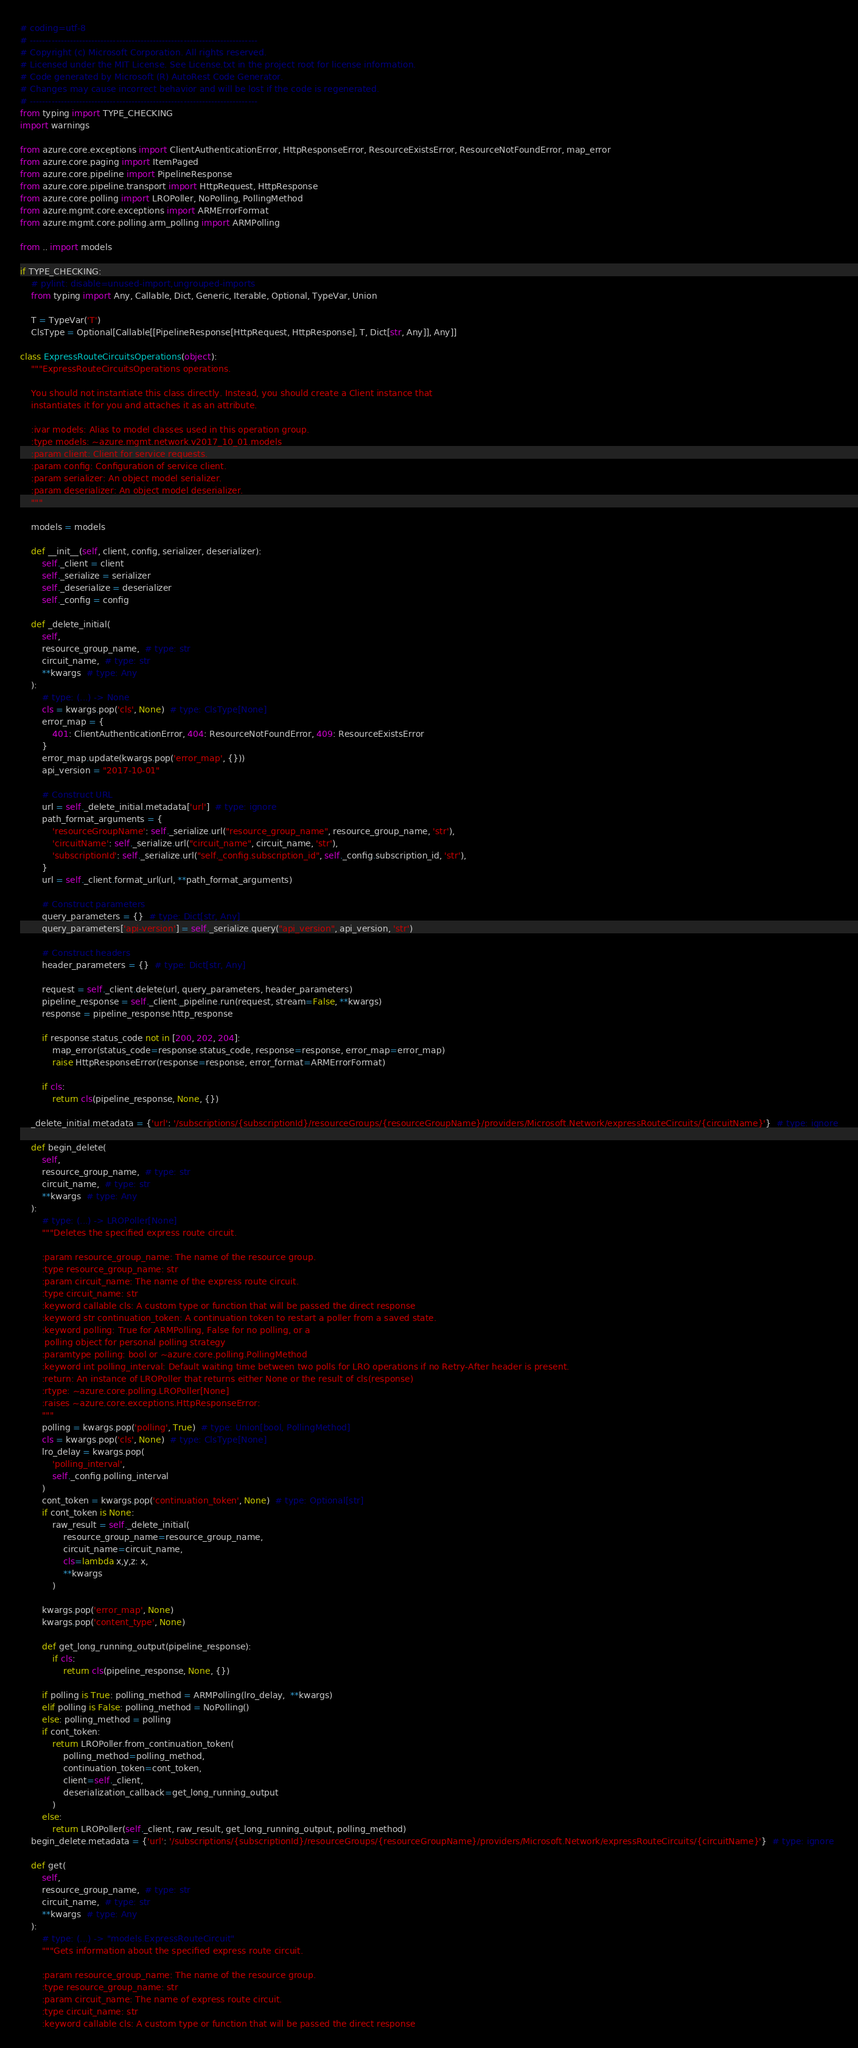<code> <loc_0><loc_0><loc_500><loc_500><_Python_># coding=utf-8
# --------------------------------------------------------------------------
# Copyright (c) Microsoft Corporation. All rights reserved.
# Licensed under the MIT License. See License.txt in the project root for license information.
# Code generated by Microsoft (R) AutoRest Code Generator.
# Changes may cause incorrect behavior and will be lost if the code is regenerated.
# --------------------------------------------------------------------------
from typing import TYPE_CHECKING
import warnings

from azure.core.exceptions import ClientAuthenticationError, HttpResponseError, ResourceExistsError, ResourceNotFoundError, map_error
from azure.core.paging import ItemPaged
from azure.core.pipeline import PipelineResponse
from azure.core.pipeline.transport import HttpRequest, HttpResponse
from azure.core.polling import LROPoller, NoPolling, PollingMethod
from azure.mgmt.core.exceptions import ARMErrorFormat
from azure.mgmt.core.polling.arm_polling import ARMPolling

from .. import models

if TYPE_CHECKING:
    # pylint: disable=unused-import,ungrouped-imports
    from typing import Any, Callable, Dict, Generic, Iterable, Optional, TypeVar, Union

    T = TypeVar('T')
    ClsType = Optional[Callable[[PipelineResponse[HttpRequest, HttpResponse], T, Dict[str, Any]], Any]]

class ExpressRouteCircuitsOperations(object):
    """ExpressRouteCircuitsOperations operations.

    You should not instantiate this class directly. Instead, you should create a Client instance that
    instantiates it for you and attaches it as an attribute.

    :ivar models: Alias to model classes used in this operation group.
    :type models: ~azure.mgmt.network.v2017_10_01.models
    :param client: Client for service requests.
    :param config: Configuration of service client.
    :param serializer: An object model serializer.
    :param deserializer: An object model deserializer.
    """

    models = models

    def __init__(self, client, config, serializer, deserializer):
        self._client = client
        self._serialize = serializer
        self._deserialize = deserializer
        self._config = config

    def _delete_initial(
        self,
        resource_group_name,  # type: str
        circuit_name,  # type: str
        **kwargs  # type: Any
    ):
        # type: (...) -> None
        cls = kwargs.pop('cls', None)  # type: ClsType[None]
        error_map = {
            401: ClientAuthenticationError, 404: ResourceNotFoundError, 409: ResourceExistsError
        }
        error_map.update(kwargs.pop('error_map', {}))
        api_version = "2017-10-01"

        # Construct URL
        url = self._delete_initial.metadata['url']  # type: ignore
        path_format_arguments = {
            'resourceGroupName': self._serialize.url("resource_group_name", resource_group_name, 'str'),
            'circuitName': self._serialize.url("circuit_name", circuit_name, 'str'),
            'subscriptionId': self._serialize.url("self._config.subscription_id", self._config.subscription_id, 'str'),
        }
        url = self._client.format_url(url, **path_format_arguments)

        # Construct parameters
        query_parameters = {}  # type: Dict[str, Any]
        query_parameters['api-version'] = self._serialize.query("api_version", api_version, 'str')

        # Construct headers
        header_parameters = {}  # type: Dict[str, Any]

        request = self._client.delete(url, query_parameters, header_parameters)
        pipeline_response = self._client._pipeline.run(request, stream=False, **kwargs)
        response = pipeline_response.http_response

        if response.status_code not in [200, 202, 204]:
            map_error(status_code=response.status_code, response=response, error_map=error_map)
            raise HttpResponseError(response=response, error_format=ARMErrorFormat)

        if cls:
            return cls(pipeline_response, None, {})

    _delete_initial.metadata = {'url': '/subscriptions/{subscriptionId}/resourceGroups/{resourceGroupName}/providers/Microsoft.Network/expressRouteCircuits/{circuitName}'}  # type: ignore

    def begin_delete(
        self,
        resource_group_name,  # type: str
        circuit_name,  # type: str
        **kwargs  # type: Any
    ):
        # type: (...) -> LROPoller[None]
        """Deletes the specified express route circuit.

        :param resource_group_name: The name of the resource group.
        :type resource_group_name: str
        :param circuit_name: The name of the express route circuit.
        :type circuit_name: str
        :keyword callable cls: A custom type or function that will be passed the direct response
        :keyword str continuation_token: A continuation token to restart a poller from a saved state.
        :keyword polling: True for ARMPolling, False for no polling, or a
         polling object for personal polling strategy
        :paramtype polling: bool or ~azure.core.polling.PollingMethod
        :keyword int polling_interval: Default waiting time between two polls for LRO operations if no Retry-After header is present.
        :return: An instance of LROPoller that returns either None or the result of cls(response)
        :rtype: ~azure.core.polling.LROPoller[None]
        :raises ~azure.core.exceptions.HttpResponseError:
        """
        polling = kwargs.pop('polling', True)  # type: Union[bool, PollingMethod]
        cls = kwargs.pop('cls', None)  # type: ClsType[None]
        lro_delay = kwargs.pop(
            'polling_interval',
            self._config.polling_interval
        )
        cont_token = kwargs.pop('continuation_token', None)  # type: Optional[str]
        if cont_token is None:
            raw_result = self._delete_initial(
                resource_group_name=resource_group_name,
                circuit_name=circuit_name,
                cls=lambda x,y,z: x,
                **kwargs
            )

        kwargs.pop('error_map', None)
        kwargs.pop('content_type', None)

        def get_long_running_output(pipeline_response):
            if cls:
                return cls(pipeline_response, None, {})

        if polling is True: polling_method = ARMPolling(lro_delay,  **kwargs)
        elif polling is False: polling_method = NoPolling()
        else: polling_method = polling
        if cont_token:
            return LROPoller.from_continuation_token(
                polling_method=polling_method,
                continuation_token=cont_token,
                client=self._client,
                deserialization_callback=get_long_running_output
            )
        else:
            return LROPoller(self._client, raw_result, get_long_running_output, polling_method)
    begin_delete.metadata = {'url': '/subscriptions/{subscriptionId}/resourceGroups/{resourceGroupName}/providers/Microsoft.Network/expressRouteCircuits/{circuitName}'}  # type: ignore

    def get(
        self,
        resource_group_name,  # type: str
        circuit_name,  # type: str
        **kwargs  # type: Any
    ):
        # type: (...) -> "models.ExpressRouteCircuit"
        """Gets information about the specified express route circuit.

        :param resource_group_name: The name of the resource group.
        :type resource_group_name: str
        :param circuit_name: The name of express route circuit.
        :type circuit_name: str
        :keyword callable cls: A custom type or function that will be passed the direct response</code> 